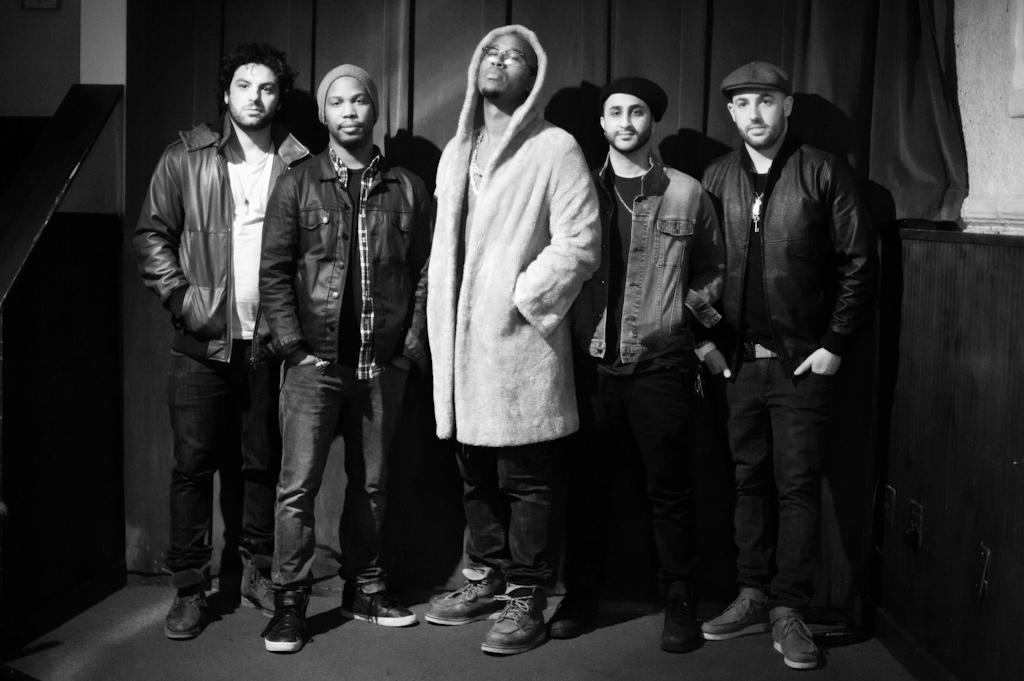How would you summarize this image in a sentence or two? In this picture we can see a group of people standing on the ground and in the background we can see an object, wall and curtain. 